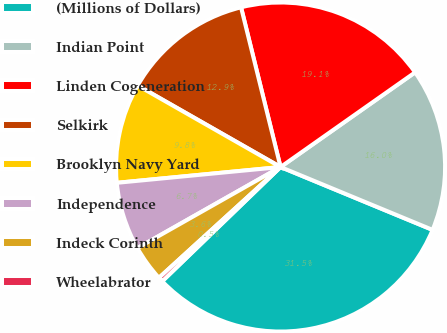Convert chart to OTSL. <chart><loc_0><loc_0><loc_500><loc_500><pie_chart><fcel>(Millions of Dollars)<fcel>Indian Point<fcel>Linden Cogeneration<fcel>Selkirk<fcel>Brooklyn Navy Yard<fcel>Independence<fcel>Indeck Corinth<fcel>Wheelabrator<nl><fcel>31.54%<fcel>16.0%<fcel>19.1%<fcel>12.89%<fcel>9.78%<fcel>6.67%<fcel>3.56%<fcel>0.46%<nl></chart> 